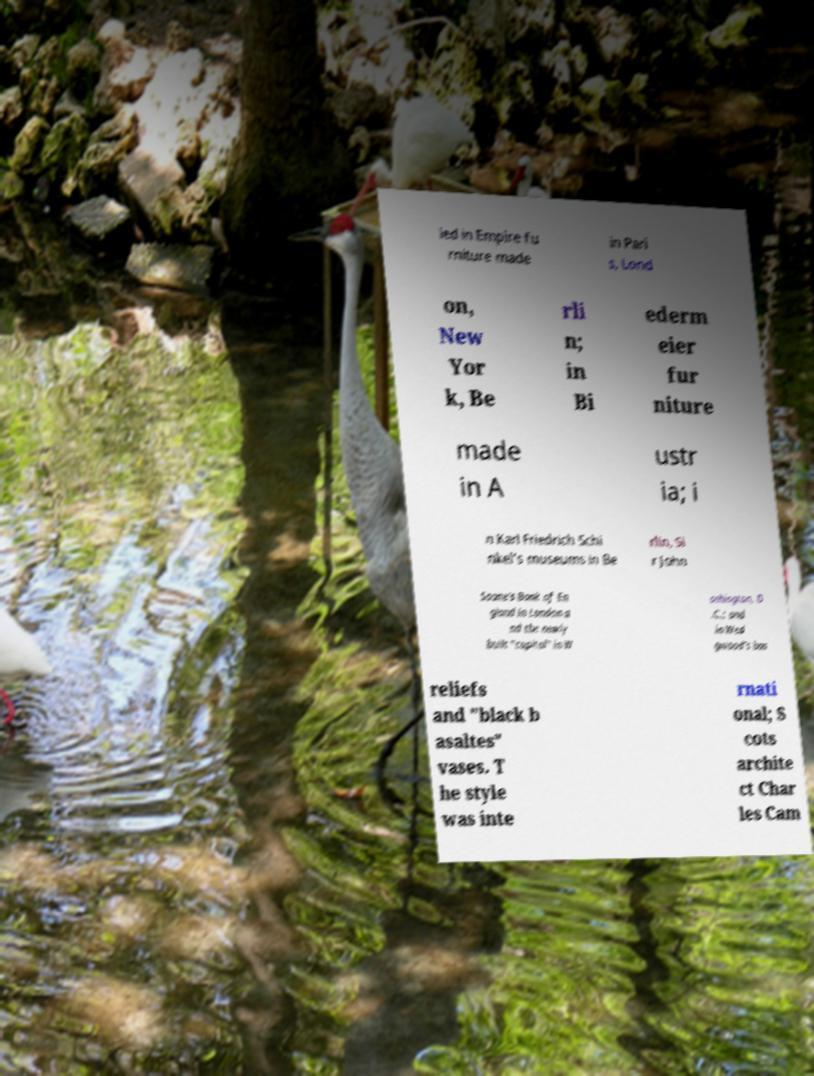For documentation purposes, I need the text within this image transcribed. Could you provide that? ied in Empire fu rniture made in Pari s, Lond on, New Yor k, Be rli n; in Bi ederm eier fur niture made in A ustr ia; i n Karl Friedrich Schi nkel's museums in Be rlin, Si r John Soane's Bank of En gland in London a nd the newly built "capitol" in W ashington, D .C.; and in Wed gwood's bas reliefs and "black b asaltes" vases. T he style was inte rnati onal; S cots archite ct Char les Cam 